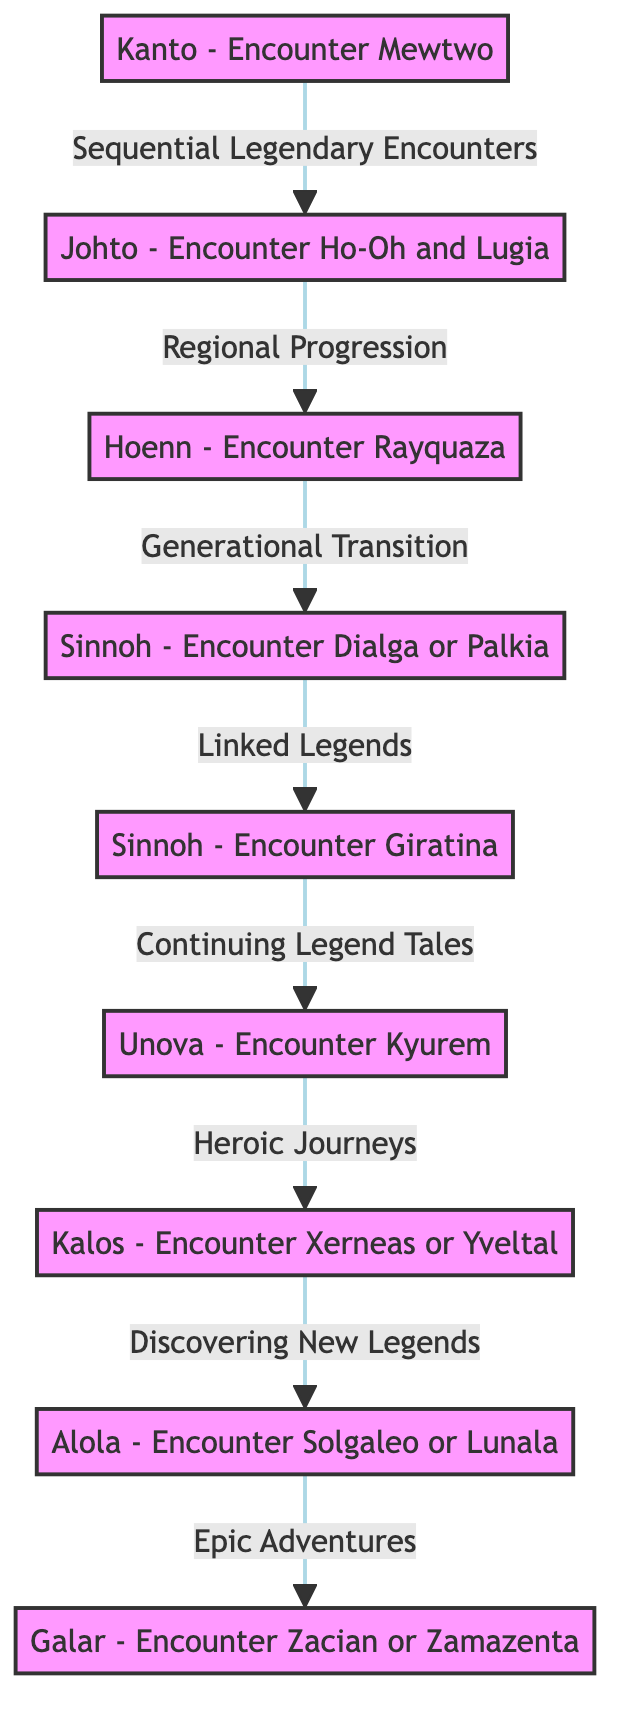What is the starting encounter in this timeline? The diagram starts with the encounter of Mewtwo in Kanto, which is indicated as the first node in the directed graph.
Answer: Kanto - Encounter Mewtwo How many total encounters are listed in the diagram? By counting the nodes in the diagram, there are 9 encounters represented, showing the progression across regions and legendary Pokémon.
Answer: 9 What legendary Pokémon do you encounter after Ho-Oh or Lugia? Following the Johto encounter of Ho-Oh or Lugia, the diagram shows that the next encounter is with Rayquaza in Hoenn, which is connected sequentially.
Answer: Hoenn - Encounter Rayquaza Which legendary Pokémon is available after Dialga or Palkia? The graph indicates that Giratina can be encountered after interacting with either Dialga or Palkia at the Spear Pillar in Sinnoh.
Answer: Sinnoh - Encounter Giratina In which region do you encounter Xerneas or Yveltal? The diagram specifies the encounter with Xerneas or Yveltal in Kalos, as shown in the corresponding node connected after Unova's Kyurem.
Answer: Kalos - Encounter Xerneas or Yveltal Which encounter represents the final transition in this timeline? The last node in the directed graph leads to the encounter with Zacian or Zamazenta in Galar, signifying the end of the timeline's legendary encounters.
Answer: Galar - Encounter Zacian or Zamazenta What type of relationship connects Hoenn and Sinnoh encounters? The edges between Hoenn's Rayquaza and Sinnoh's Dialga or Palkia are labeled "Generational Transition," indicating a shift to the next generation of Pokémon.
Answer: Generational Transition How many edges are present in the diagram? By examining the connections between the nodes, it is noted that there are 8 edges, showing the sequential flow from one legendary encounter to the next.
Answer: 8 What does the term "Linked Legends" refer to in the diagram? The edge labeled "Linked Legends" shows the relationship between the encounters of Dialga or Palkia and Giratina, indicating that Giratina is only accessible after encountering one of the other two.
Answer: Linked Legends 